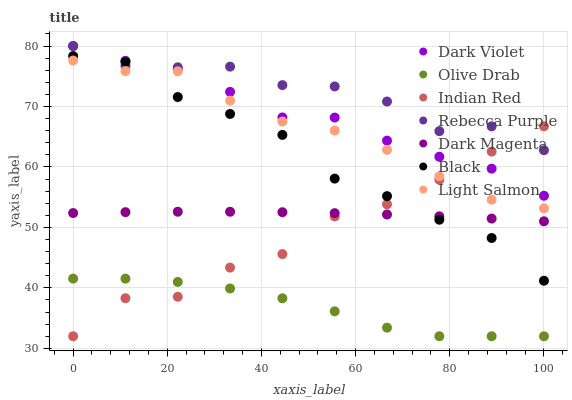Does Olive Drab have the minimum area under the curve?
Answer yes or no. Yes. Does Rebecca Purple have the maximum area under the curve?
Answer yes or no. Yes. Does Dark Magenta have the minimum area under the curve?
Answer yes or no. No. Does Dark Magenta have the maximum area under the curve?
Answer yes or no. No. Is Dark Magenta the smoothest?
Answer yes or no. Yes. Is Indian Red the roughest?
Answer yes or no. Yes. Is Dark Violet the smoothest?
Answer yes or no. No. Is Dark Violet the roughest?
Answer yes or no. No. Does Indian Red have the lowest value?
Answer yes or no. Yes. Does Dark Magenta have the lowest value?
Answer yes or no. No. Does Rebecca Purple have the highest value?
Answer yes or no. Yes. Does Dark Magenta have the highest value?
Answer yes or no. No. Is Dark Magenta less than Dark Violet?
Answer yes or no. Yes. Is Light Salmon greater than Olive Drab?
Answer yes or no. Yes. Does Black intersect Light Salmon?
Answer yes or no. Yes. Is Black less than Light Salmon?
Answer yes or no. No. Is Black greater than Light Salmon?
Answer yes or no. No. Does Dark Magenta intersect Dark Violet?
Answer yes or no. No. 